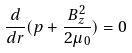Convert formula to latex. <formula><loc_0><loc_0><loc_500><loc_500>\frac { d } { d r } ( p + \frac { B _ { z } ^ { 2 } } { 2 \mu _ { 0 } } ) = 0</formula> 